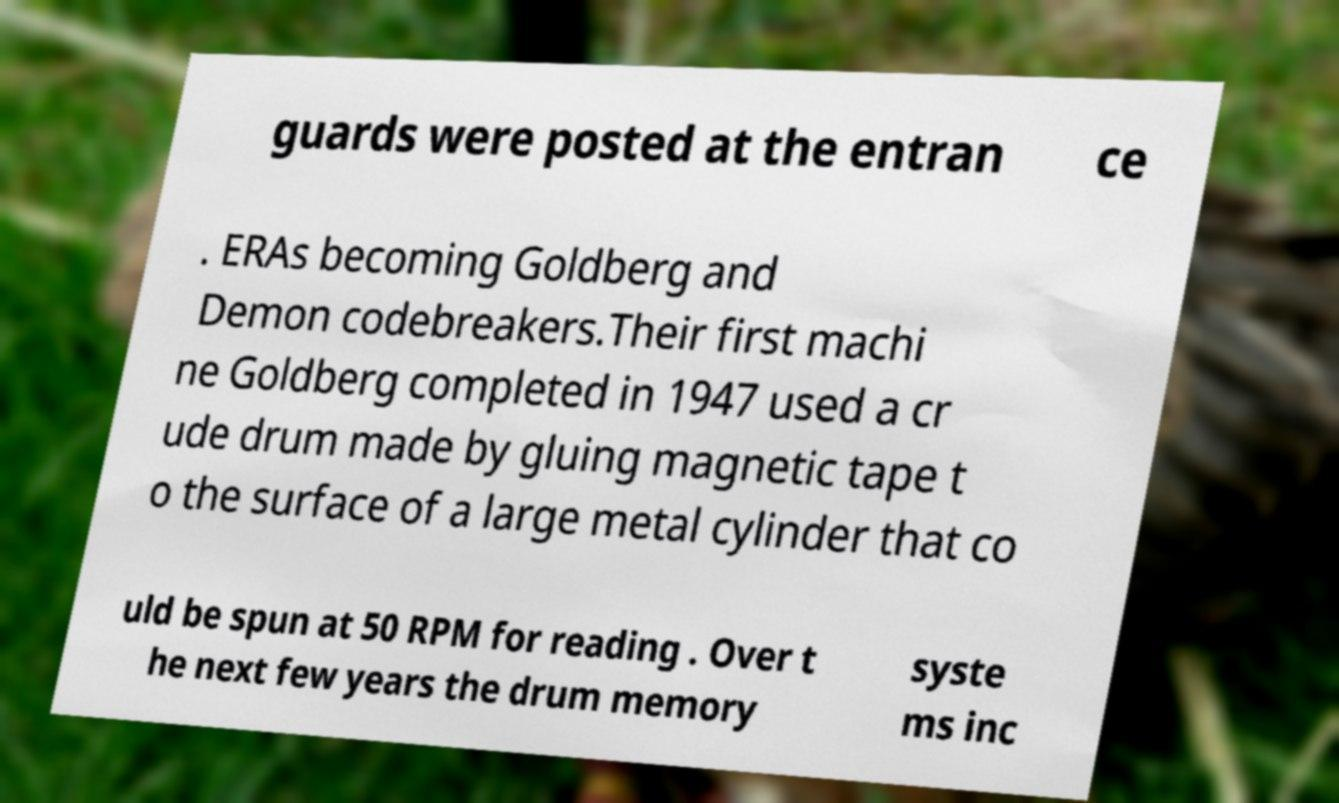Could you assist in decoding the text presented in this image and type it out clearly? guards were posted at the entran ce . ERAs becoming Goldberg and Demon codebreakers.Their first machi ne Goldberg completed in 1947 used a cr ude drum made by gluing magnetic tape t o the surface of a large metal cylinder that co uld be spun at 50 RPM for reading . Over t he next few years the drum memory syste ms inc 